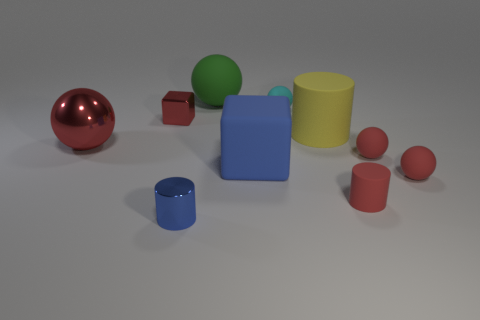How many matte cylinders have the same color as the small metal block?
Keep it short and to the point. 1. What is the color of the ball that is both behind the big block and to the right of the big matte cylinder?
Ensure brevity in your answer.  Red. There is a tiny red object to the left of the tiny cyan matte sphere; what is its shape?
Offer a terse response. Cube. How big is the cylinder that is to the left of the big sphere that is to the right of the small metallic thing that is behind the big block?
Provide a short and direct response. Small. What number of large matte spheres are in front of the tiny metallic thing behind the blue cylinder?
Your answer should be very brief. 0. There is a rubber thing that is both in front of the large blue block and behind the tiny red cylinder; how big is it?
Your response must be concise. Small. How many shiny things are red spheres or large balls?
Offer a very short reply. 1. What is the large cylinder made of?
Give a very brief answer. Rubber. What is the tiny object in front of the matte cylinder that is in front of the big matte thing that is right of the cyan rubber sphere made of?
Provide a succinct answer. Metal. The cyan rubber object that is the same size as the red metallic block is what shape?
Your response must be concise. Sphere. 